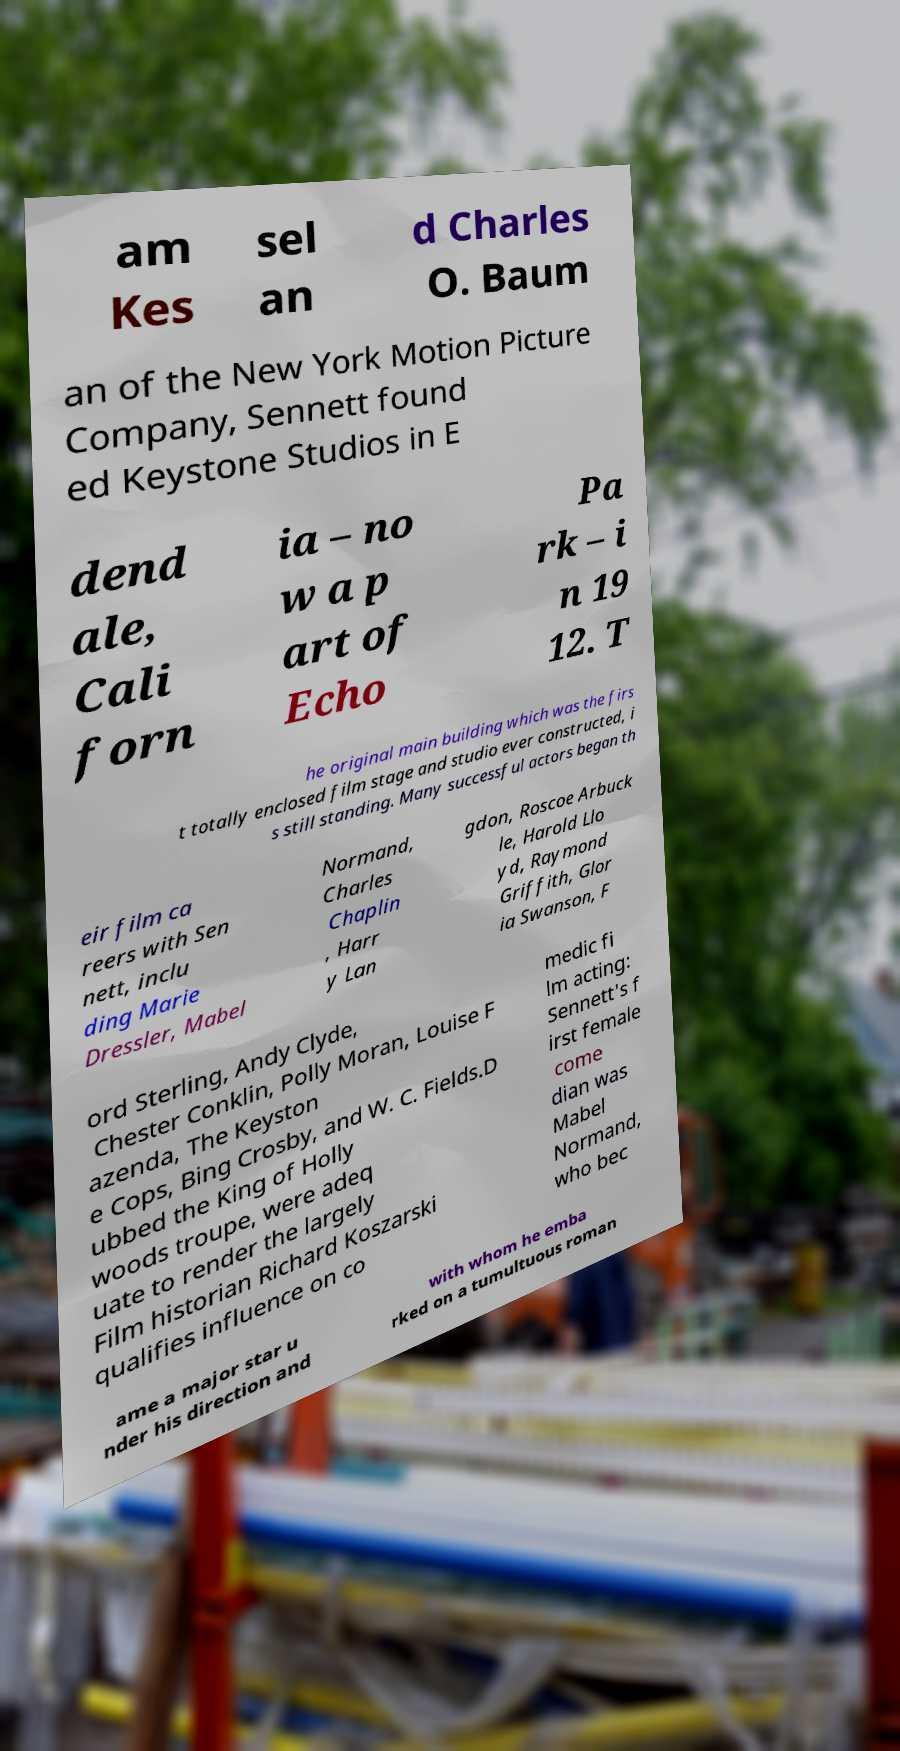I need the written content from this picture converted into text. Can you do that? am Kes sel an d Charles O. Baum an of the New York Motion Picture Company, Sennett found ed Keystone Studios in E dend ale, Cali forn ia – no w a p art of Echo Pa rk – i n 19 12. T he original main building which was the firs t totally enclosed film stage and studio ever constructed, i s still standing. Many successful actors began th eir film ca reers with Sen nett, inclu ding Marie Dressler, Mabel Normand, Charles Chaplin , Harr y Lan gdon, Roscoe Arbuck le, Harold Llo yd, Raymond Griffith, Glor ia Swanson, F ord Sterling, Andy Clyde, Chester Conklin, Polly Moran, Louise F azenda, The Keyston e Cops, Bing Crosby, and W. C. Fields.D ubbed the King of Holly woods troupe, were adeq uate to render the largely Film historian Richard Koszarski qualifies influence on co medic fi lm acting: Sennett's f irst female come dian was Mabel Normand, who bec ame a major star u nder his direction and with whom he emba rked on a tumultuous roman 